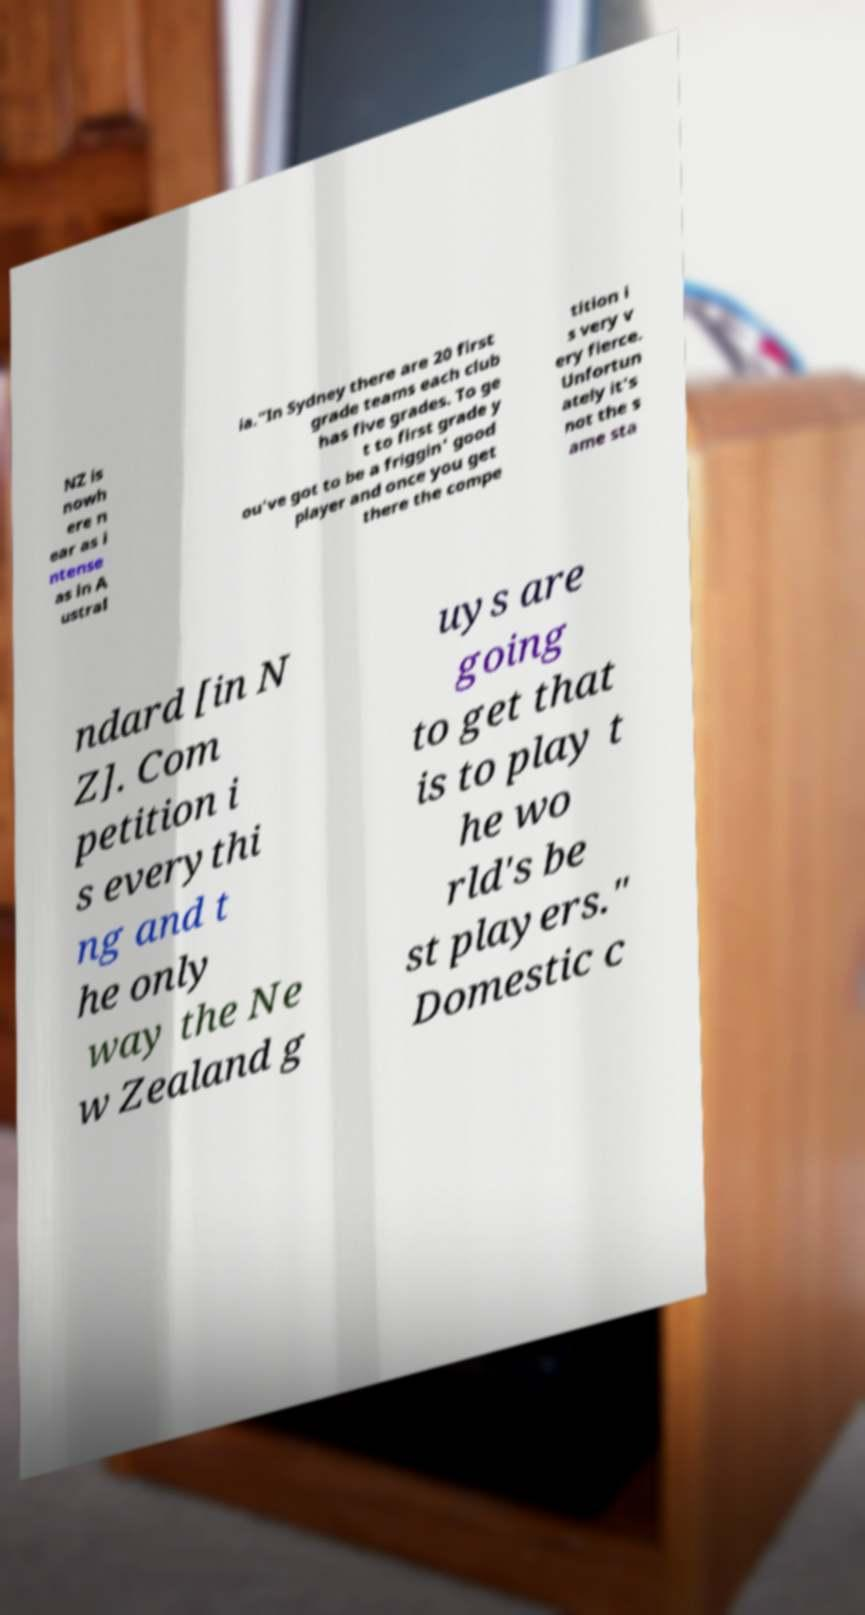What messages or text are displayed in this image? I need them in a readable, typed format. NZ is nowh ere n ear as i ntense as in A ustral ia."In Sydney there are 20 first grade teams each club has five grades. To ge t to first grade y ou've got to be a friggin' good player and once you get there the compe tition i s very v ery fierce. Unfortun ately it's not the s ame sta ndard [in N Z]. Com petition i s everythi ng and t he only way the Ne w Zealand g uys are going to get that is to play t he wo rld's be st players." Domestic c 